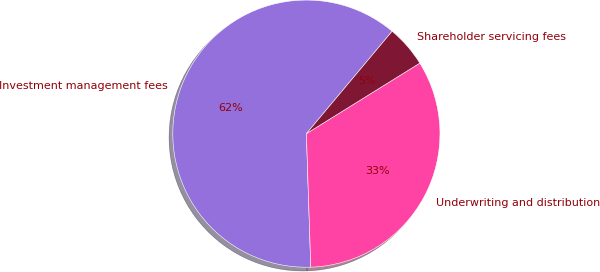<chart> <loc_0><loc_0><loc_500><loc_500><pie_chart><fcel>Investment management fees<fcel>Underwriting and distribution<fcel>Shareholder servicing fees<nl><fcel>61.62%<fcel>33.33%<fcel>5.05%<nl></chart> 